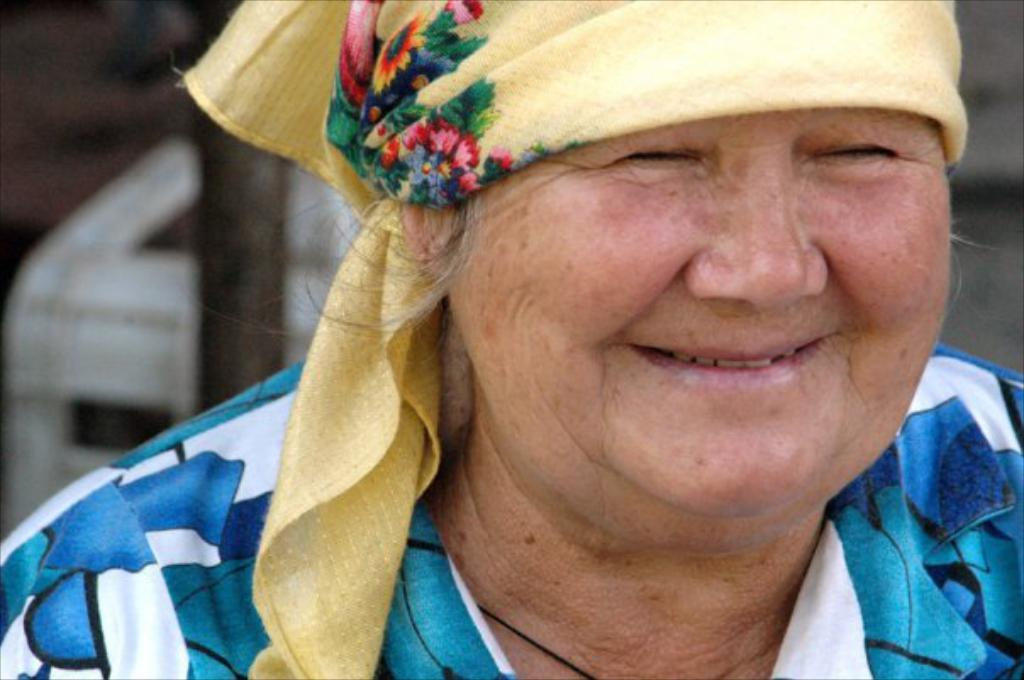Who is the main subject in the image? There is an old lady in the image. What is the old lady doing in the image? The old lady is smiling. What is the old lady wearing on her head? The old lady is wearing a yellow scarf on her head. What color is the old lady's shirt? The old lady is wearing a blue and white shirt. What type of joke is the old lady telling in the image? There is no indication in the image that the old lady is telling a joke, so it cannot be determined from the picture. 